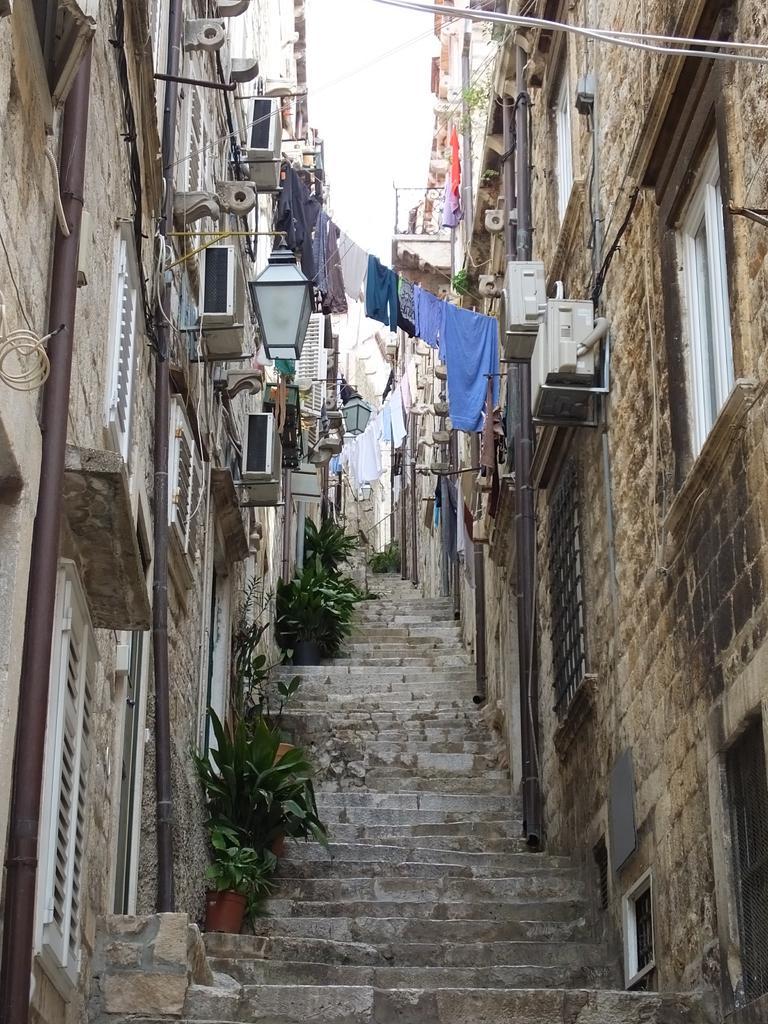Describe this image in one or two sentences. In this image we can see few buildings. There are few clothes in the image. There are staircases in the image. We can see the sky in the image. There are few plants in the image. There are few objects on the wall. 